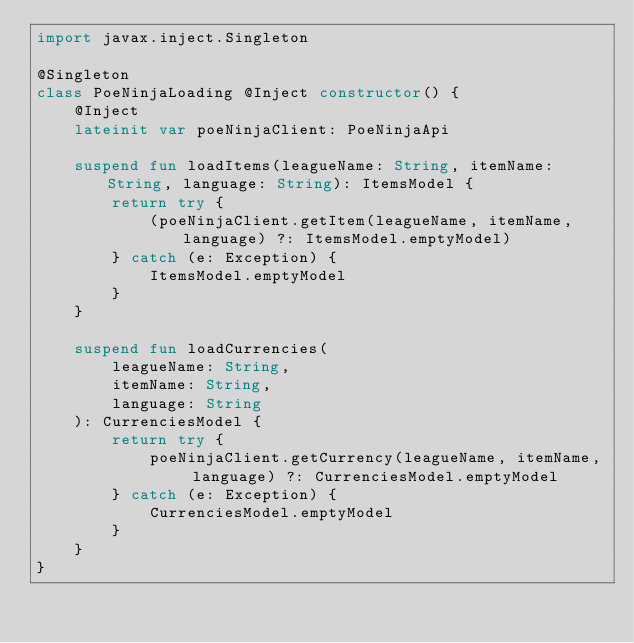<code> <loc_0><loc_0><loc_500><loc_500><_Kotlin_>import javax.inject.Singleton

@Singleton
class PoeNinjaLoading @Inject constructor() {
    @Inject
    lateinit var poeNinjaClient: PoeNinjaApi

    suspend fun loadItems(leagueName: String, itemName: String, language: String): ItemsModel {
        return try {
            (poeNinjaClient.getItem(leagueName, itemName, language) ?: ItemsModel.emptyModel)
        } catch (e: Exception) {
            ItemsModel.emptyModel
        }
    }

    suspend fun loadCurrencies(
        leagueName: String,
        itemName: String,
        language: String
    ): CurrenciesModel {
        return try {
            poeNinjaClient.getCurrency(leagueName, itemName, language) ?: CurrenciesModel.emptyModel
        } catch (e: Exception) {
            CurrenciesModel.emptyModel
        }
    }
}

</code> 